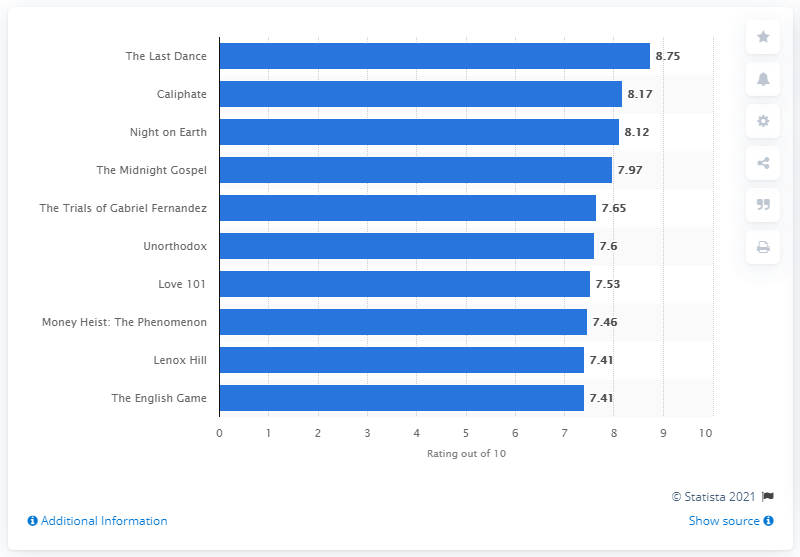Specify some key components in this picture. It is known that the second highest rated Swedish thriller series on Netflix in 2020 was "Caliphate. The highest-rated documentary on Netflix among Polish viewers in 2020 was "The Last Dance. 